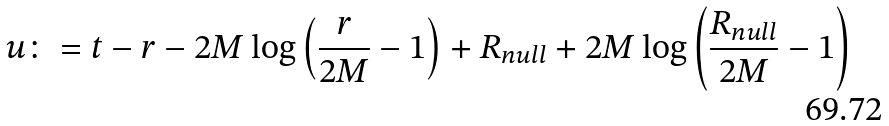Convert formula to latex. <formula><loc_0><loc_0><loc_500><loc_500>u \colon = t - r - 2 M \log \left ( \frac { r } { 2 M } - 1 \right ) + R _ { n u l l } + 2 M \log \left ( \frac { R _ { n u l l } } { 2 M } - 1 \right )</formula> 